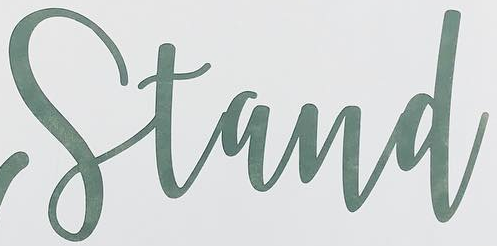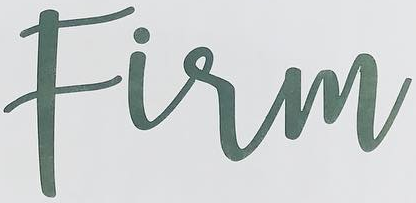Read the text content from these images in order, separated by a semicolon. Stand; Firm 